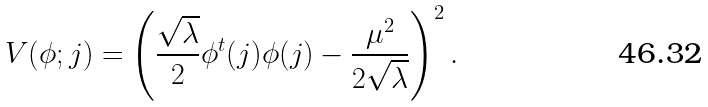<formula> <loc_0><loc_0><loc_500><loc_500>V ( \phi ; { j } ) = \left ( \frac { \sqrt { \lambda } } { 2 } \phi ^ { t } ( { j } ) \phi ( { j } ) - \frac { \mu ^ { 2 } } { 2 \sqrt { \lambda } } \right ) ^ { 2 } .</formula> 